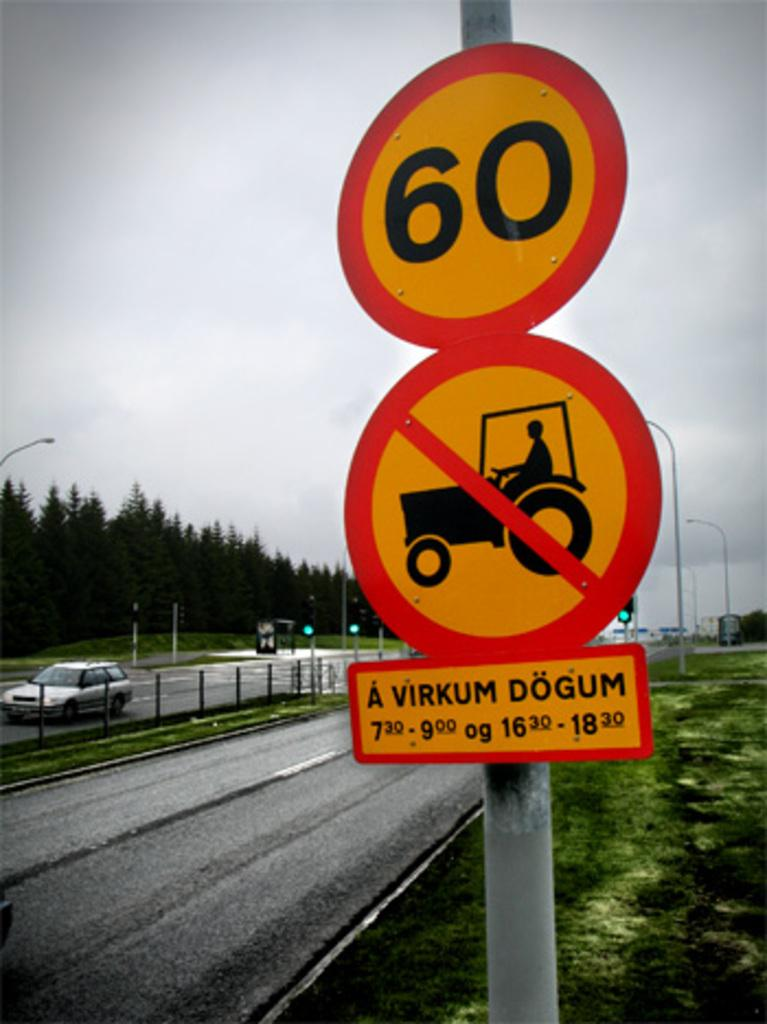<image>
Provide a brief description of the given image. Two street signs prohibiting tractors and setting the maximum speed limit to 60. 